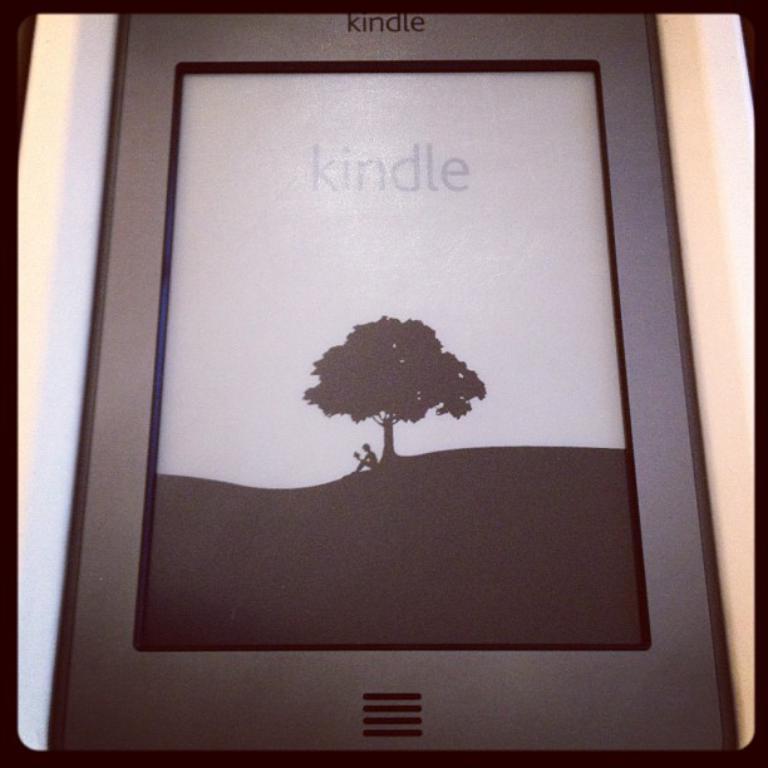How would you summarize this image in a sentence or two? In this picture I can see there is a smart phone and it has a screen, there is a person sitting under the tree and reading the book and the smart phone has a logo on it. 